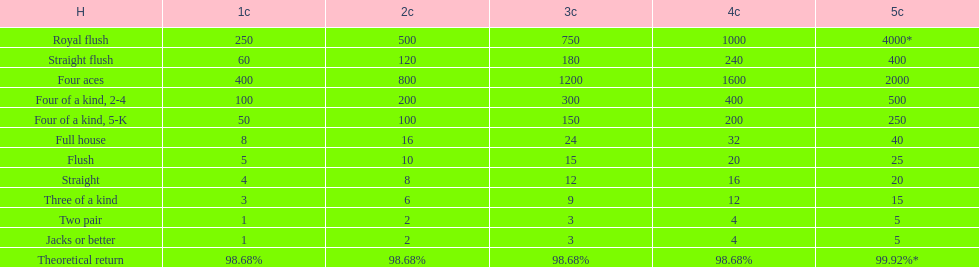Each four aces win is a multiple of what number? 400. 